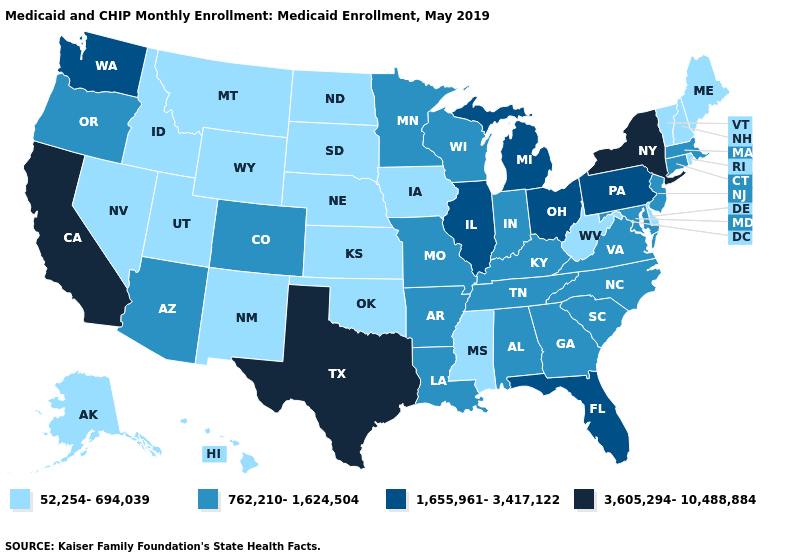Which states have the highest value in the USA?
Answer briefly. California, New York, Texas. Does the first symbol in the legend represent the smallest category?
Give a very brief answer. Yes. What is the value of Nebraska?
Give a very brief answer. 52,254-694,039. What is the value of Georgia?
Short answer required. 762,210-1,624,504. What is the highest value in states that border South Dakota?
Write a very short answer. 762,210-1,624,504. What is the value of North Dakota?
Write a very short answer. 52,254-694,039. Does Connecticut have the highest value in the Northeast?
Keep it brief. No. Name the states that have a value in the range 762,210-1,624,504?
Keep it brief. Alabama, Arizona, Arkansas, Colorado, Connecticut, Georgia, Indiana, Kentucky, Louisiana, Maryland, Massachusetts, Minnesota, Missouri, New Jersey, North Carolina, Oregon, South Carolina, Tennessee, Virginia, Wisconsin. Name the states that have a value in the range 762,210-1,624,504?
Give a very brief answer. Alabama, Arizona, Arkansas, Colorado, Connecticut, Georgia, Indiana, Kentucky, Louisiana, Maryland, Massachusetts, Minnesota, Missouri, New Jersey, North Carolina, Oregon, South Carolina, Tennessee, Virginia, Wisconsin. What is the highest value in the MidWest ?
Be succinct. 1,655,961-3,417,122. Does California have a higher value than New York?
Keep it brief. No. Does the map have missing data?
Be succinct. No. Name the states that have a value in the range 1,655,961-3,417,122?
Write a very short answer. Florida, Illinois, Michigan, Ohio, Pennsylvania, Washington. Name the states that have a value in the range 1,655,961-3,417,122?
Be succinct. Florida, Illinois, Michigan, Ohio, Pennsylvania, Washington. 